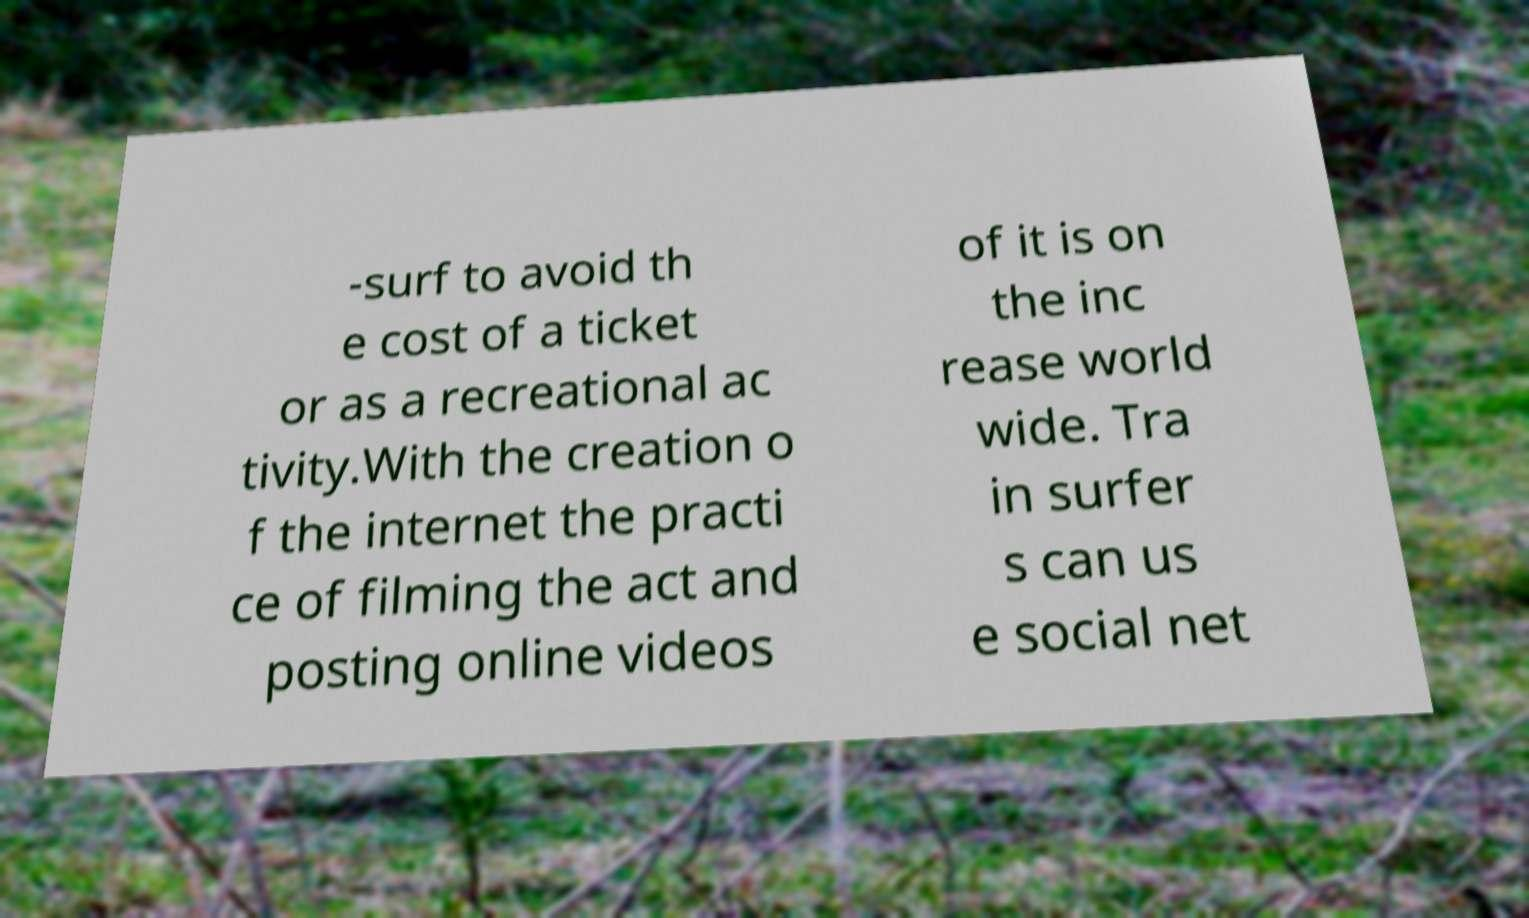Could you extract and type out the text from this image? -surf to avoid th e cost of a ticket or as a recreational ac tivity.With the creation o f the internet the practi ce of filming the act and posting online videos of it is on the inc rease world wide. Tra in surfer s can us e social net 